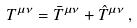<formula> <loc_0><loc_0><loc_500><loc_500>T ^ { \mu \nu } = \bar { T } ^ { \mu \nu } + \hat { T } ^ { \mu \nu } \, ,</formula> 